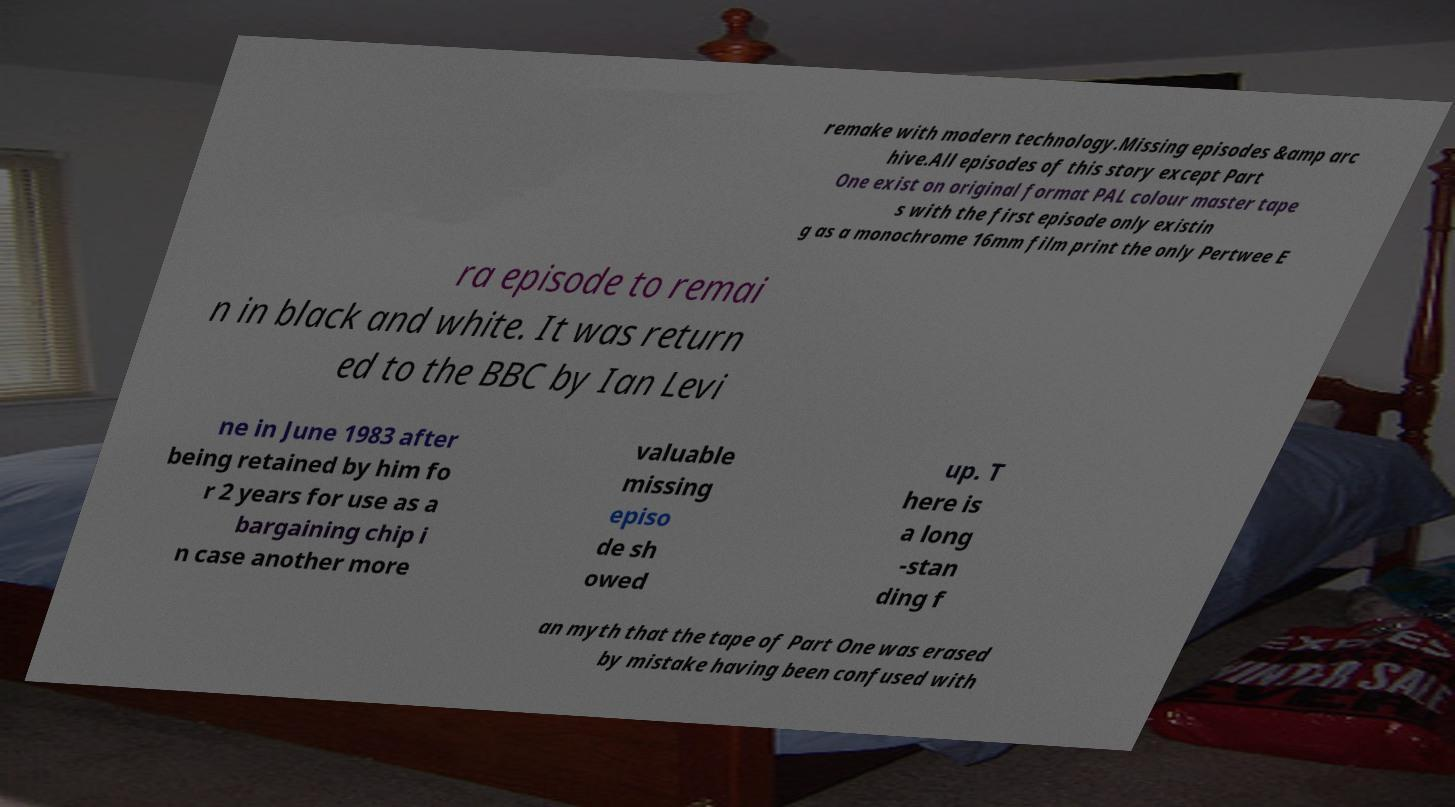What messages or text are displayed in this image? I need them in a readable, typed format. remake with modern technology.Missing episodes &amp arc hive.All episodes of this story except Part One exist on original format PAL colour master tape s with the first episode only existin g as a monochrome 16mm film print the only Pertwee E ra episode to remai n in black and white. It was return ed to the BBC by Ian Levi ne in June 1983 after being retained by him fo r 2 years for use as a bargaining chip i n case another more valuable missing episo de sh owed up. T here is a long -stan ding f an myth that the tape of Part One was erased by mistake having been confused with 